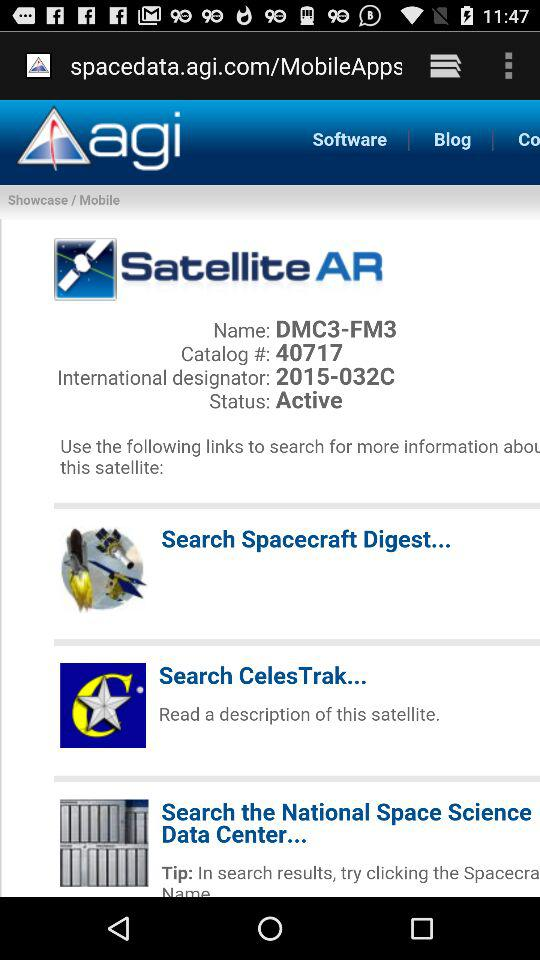What is the catalog number of the satellite? The catalog number of the satellite is 40717. 